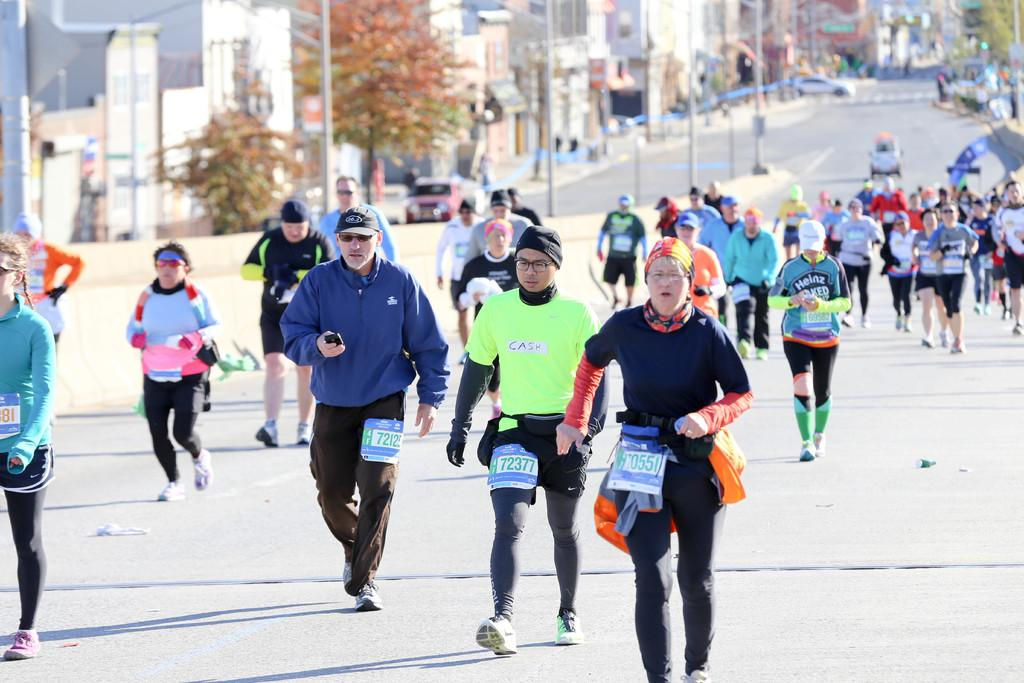What are the people in the image doing? People are walking on the road in the image. What objects can be seen along the road? There are poles in the image. What else is present on the road? There are vehicles in the image. What can be seen in the background of the image? There are trees and buildings in the image. What type of scarf is being used to control the traffic in the image? There is no scarf present in the image, and no indication of traffic control. 